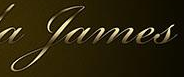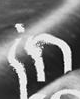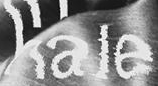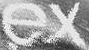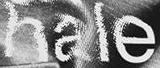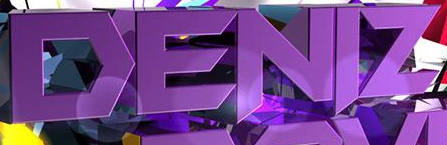Read the text from these images in sequence, separated by a semicolon. James; in; hale; ex; hale; DENIZ 